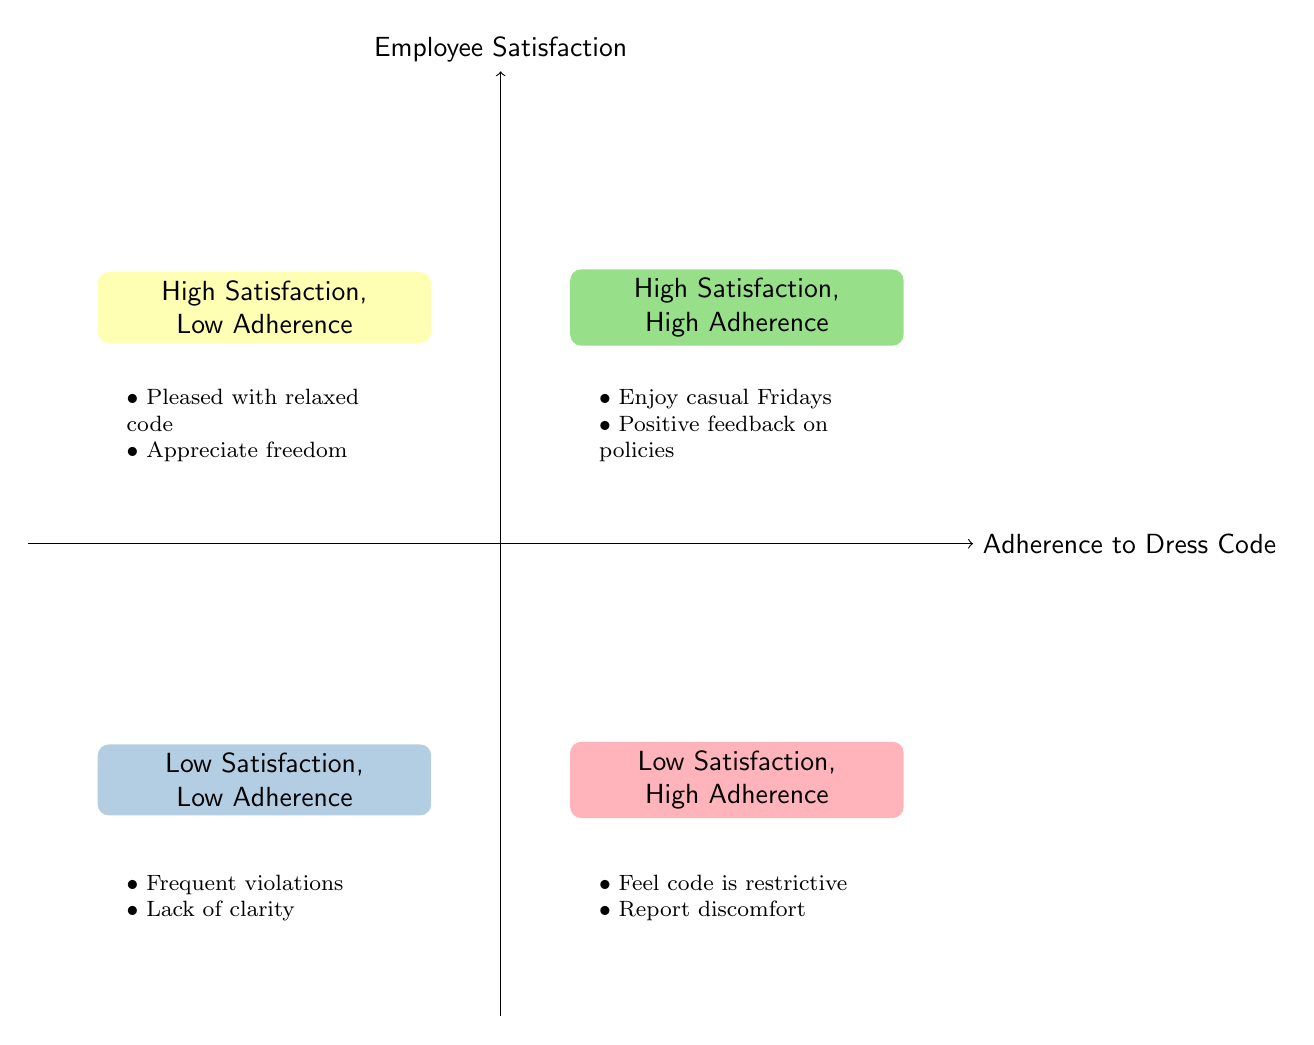What are the characteristics of the "High Satisfaction, High Adherence" quadrant? This quadrant indicates that employees are satisfied and comply with the dress code, demonstrating a balance between enjoyment and adherence. Characteristics include enjoying casual Fridays and positive feedback on policies.
Answer: Employees enjoy casual Fridays while adhering to the business casual code, positive feedback about clear, fair dress code policies What is the name of the quadrant where employees are dissatisfied despite following the dress code? This quadrant is labeled "Low Satisfaction, High Adherence," revealing that employees comply with the rules but find them overly restrictive.
Answer: Low Satisfaction, High Adherence Which quadrant depicts both low employee satisfaction and low adherence to the dress code? The quadrant titled "Low Satisfaction, Low Adherence" contains this information, indicating a lack of morale and frequent rule violations.
Answer: Low Satisfaction, Low Adherence Count the number of quadrants represented in the chart. There are four distinct quadrants showcased in the diagram, illustrating the different combinations of satisfaction and adherence.
Answer: Four What feedback do employees provide in the "High Satisfaction, Low Adherence" quadrant? In this quadrant, employees express appreciation for a relaxed dress code, despite often breaching the guidelines, showcasing a desire for freedom in attire.
Answer: Pleased with relaxed dress code, appreciate freedom of expression What do employees feel in the "Low Satisfaction, High Adherence" quadrant? Employees in this quadrant comply with dress codes but feel a sense of restriction and discomfort, indicating that strict adherence doesn't equate to satisfaction.
Answer: Feel it's too restrictive, report discomfort and dissatisfaction Which quadrant includes the phrase "Lack of clarity in dress code policies"? This phrase is found in the "Low Satisfaction, Low Adherence" quadrant, indicating that unclear policies lead to non-compliance and low morale among employees.
Answer: Low Satisfaction, Low Adherence Identify the quadrant where employees enjoy casual Fridays. The quadrant named "High Satisfaction, High Adherence" indicates that employees not only enjoy casual Fridays but also adhere to business casual expectations.
Answer: High Satisfaction, High Adherence 